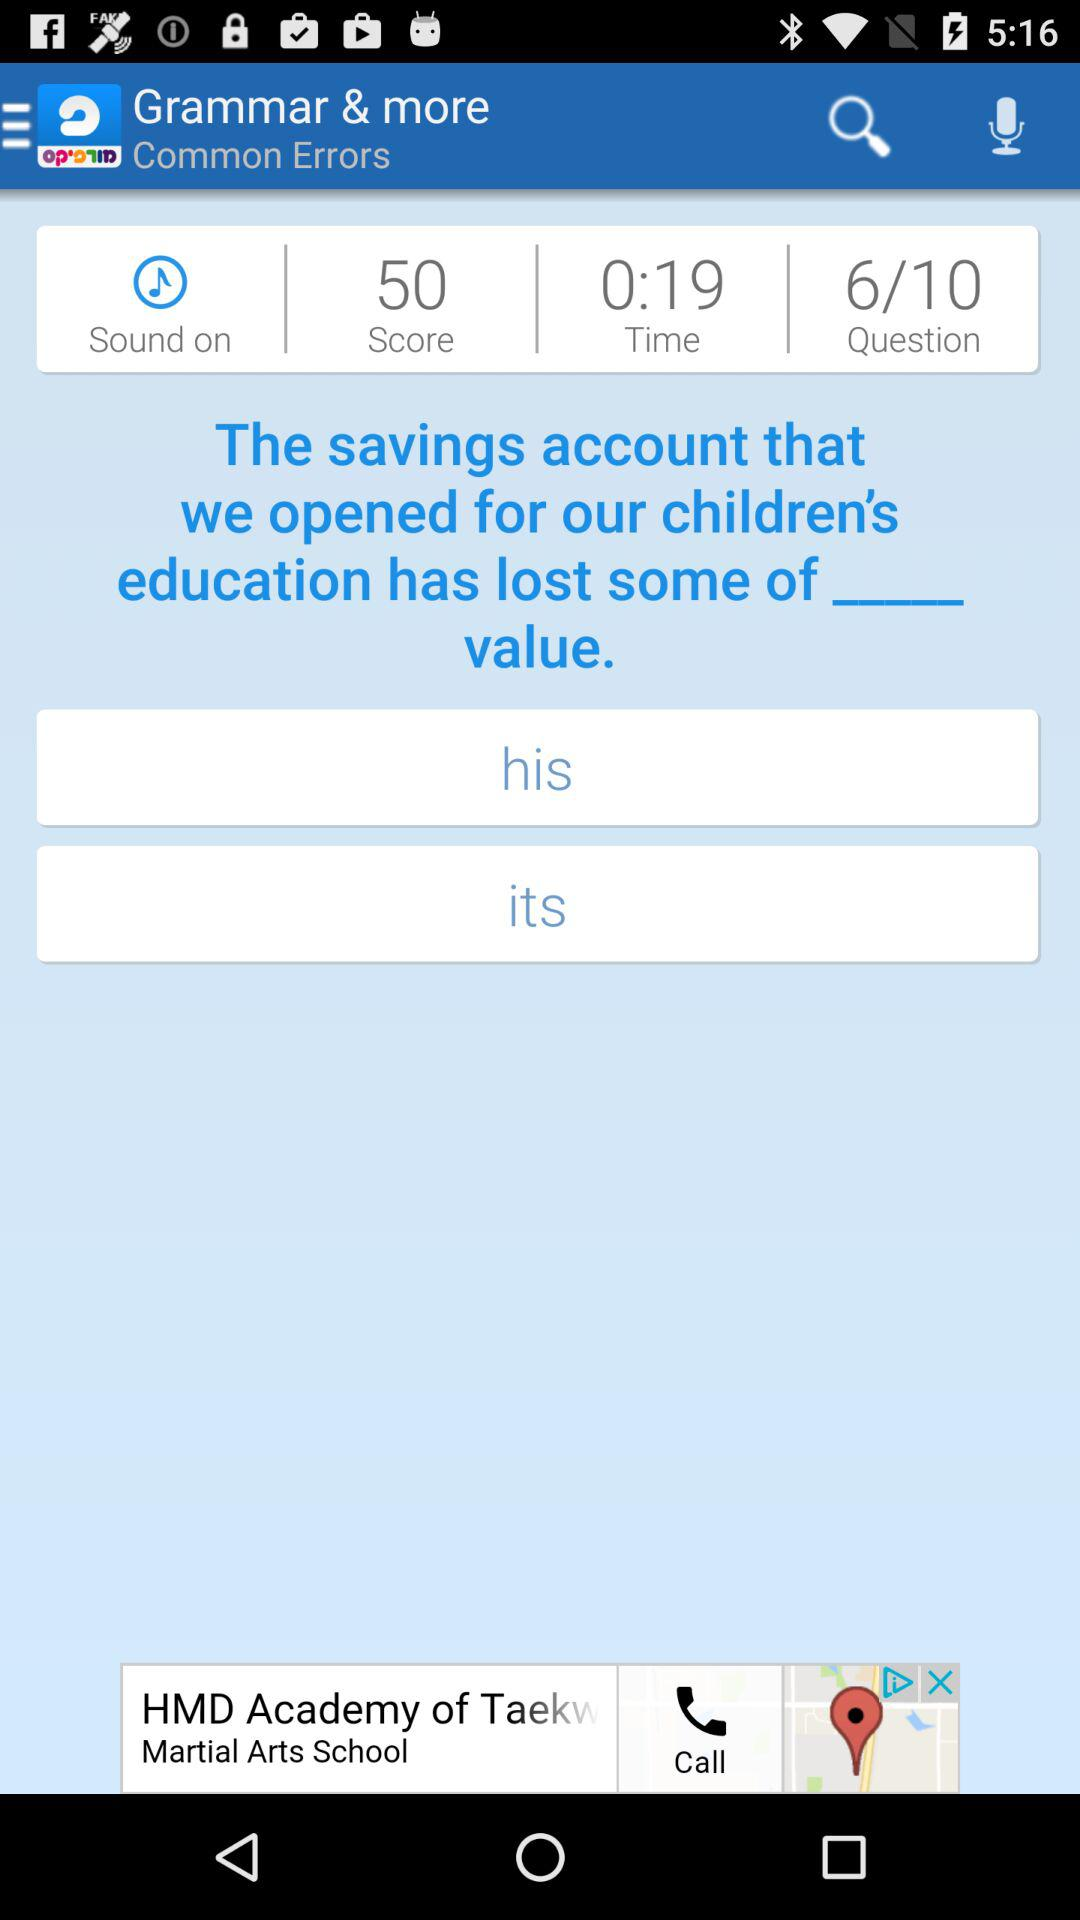What is the score? The score is 50. 